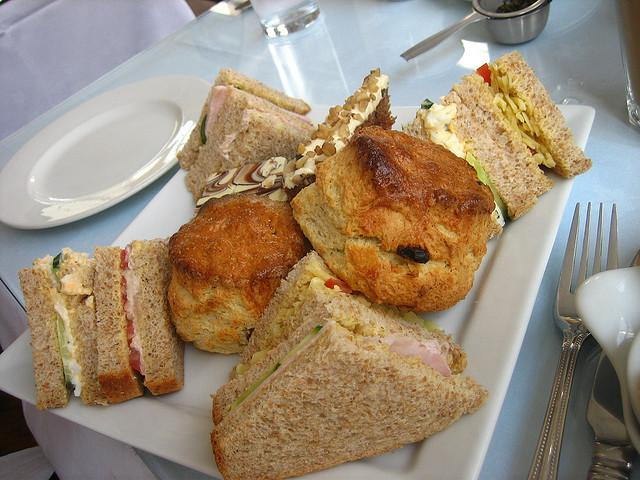What time is conducive to take the meal above? midday 